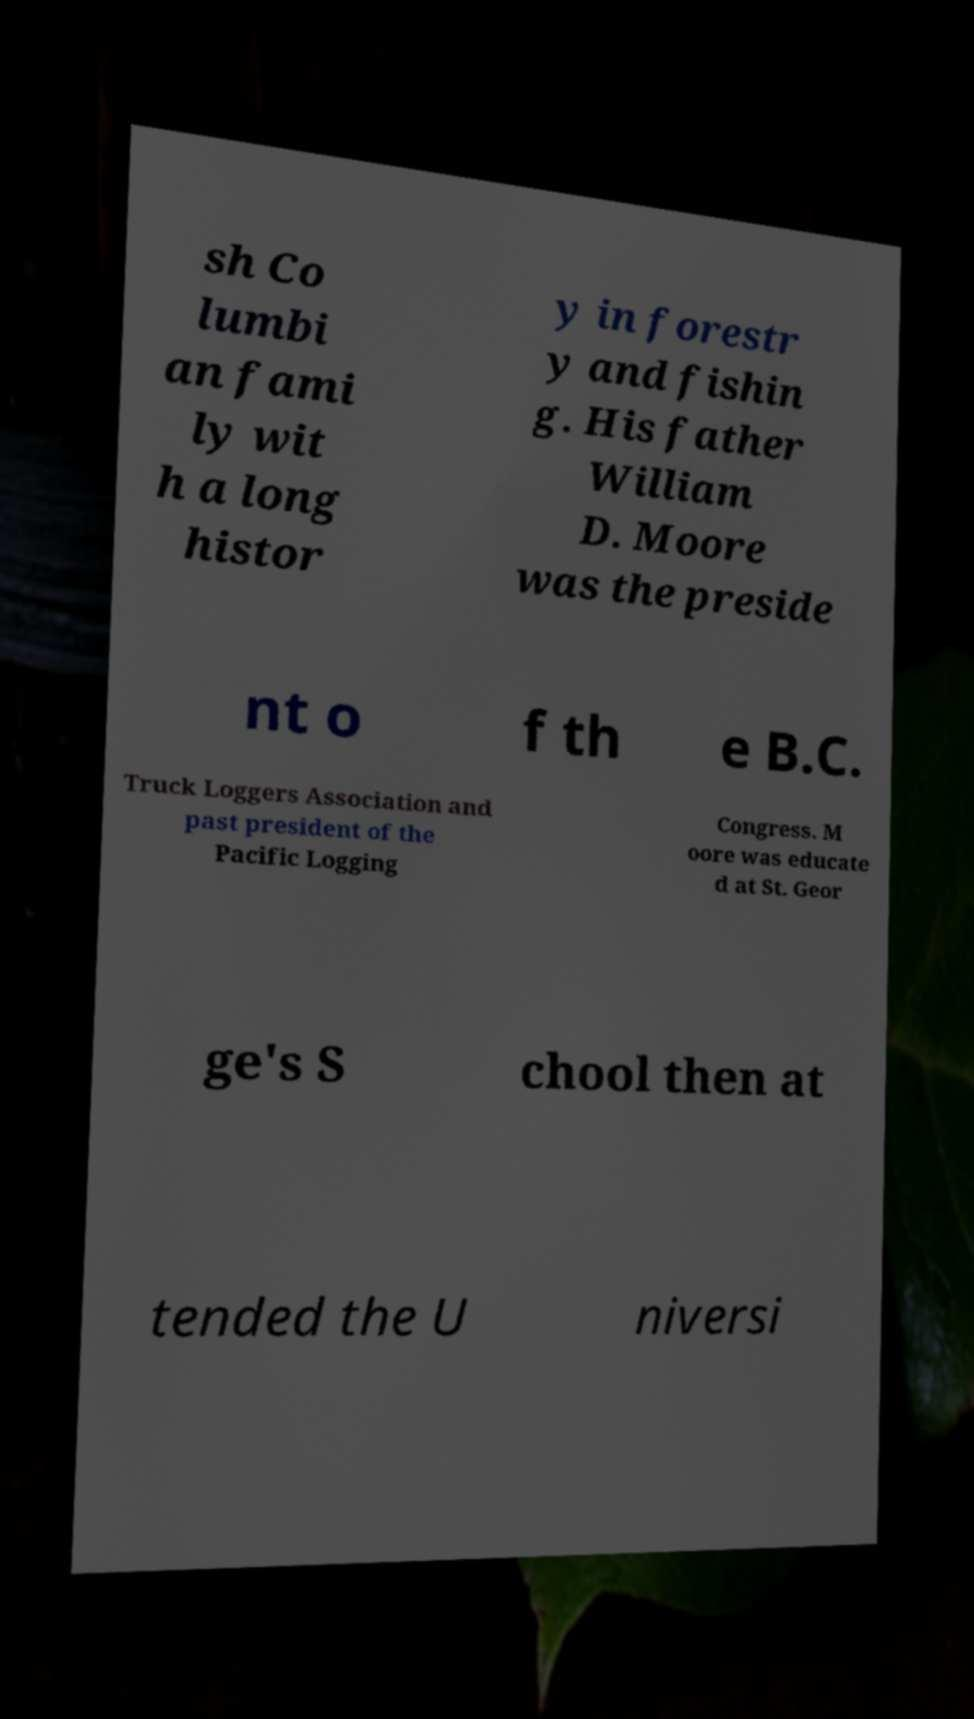What messages or text are displayed in this image? I need them in a readable, typed format. sh Co lumbi an fami ly wit h a long histor y in forestr y and fishin g. His father William D. Moore was the preside nt o f th e B.C. Truck Loggers Association and past president of the Pacific Logging Congress. M oore was educate d at St. Geor ge's S chool then at tended the U niversi 